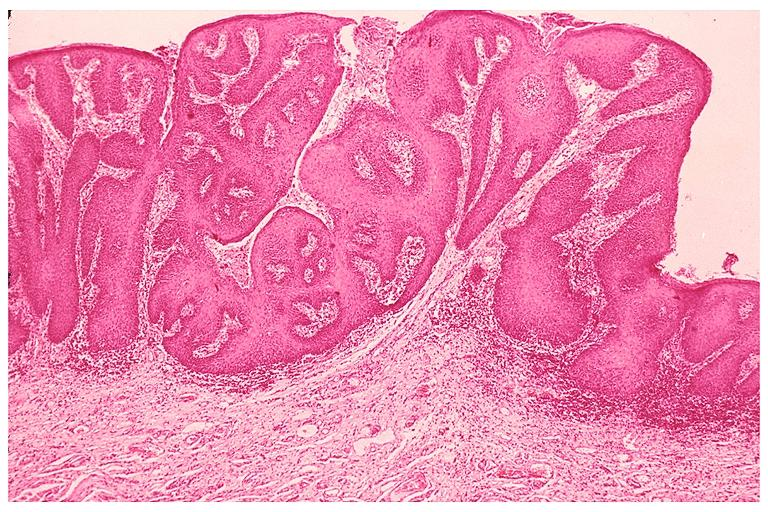s metastatic adenocarcinoma present?
Answer the question using a single word or phrase. No 